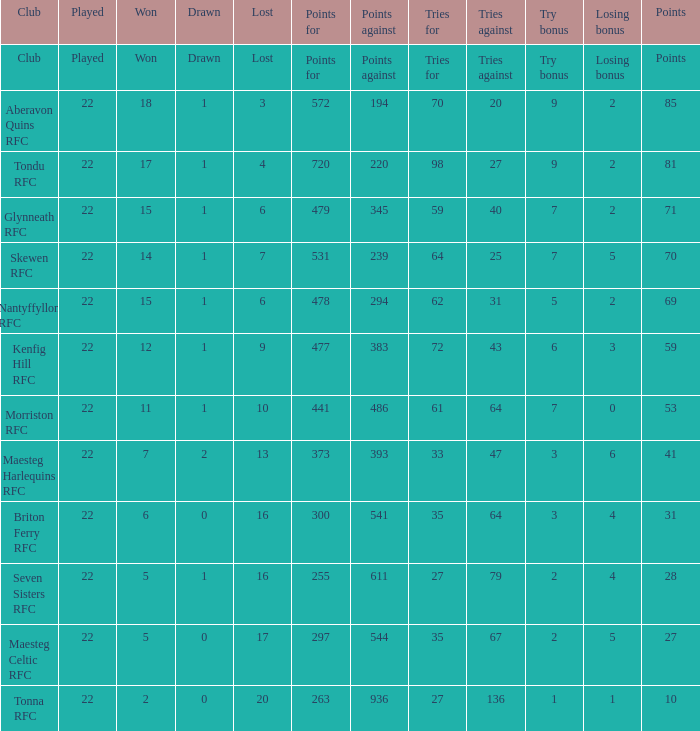Can you give me this table as a dict? {'header': ['Club', 'Played', 'Won', 'Drawn', 'Lost', 'Points for', 'Points against', 'Tries for', 'Tries against', 'Try bonus', 'Losing bonus', 'Points'], 'rows': [['Club', 'Played', 'Won', 'Drawn', 'Lost', 'Points for', 'Points against', 'Tries for', 'Tries against', 'Try bonus', 'Losing bonus', 'Points'], ['Aberavon Quins RFC', '22', '18', '1', '3', '572', '194', '70', '20', '9', '2', '85'], ['Tondu RFC', '22', '17', '1', '4', '720', '220', '98', '27', '9', '2', '81'], ['Glynneath RFC', '22', '15', '1', '6', '479', '345', '59', '40', '7', '2', '71'], ['Skewen RFC', '22', '14', '1', '7', '531', '239', '64', '25', '7', '5', '70'], ['Nantyffyllon RFC', '22', '15', '1', '6', '478', '294', '62', '31', '5', '2', '69'], ['Kenfig Hill RFC', '22', '12', '1', '9', '477', '383', '72', '43', '6', '3', '59'], ['Morriston RFC', '22', '11', '1', '10', '441', '486', '61', '64', '7', '0', '53'], ['Maesteg Harlequins RFC', '22', '7', '2', '13', '373', '393', '33', '47', '3', '6', '41'], ['Briton Ferry RFC', '22', '6', '0', '16', '300', '541', '35', '64', '3', '4', '31'], ['Seven Sisters RFC', '22', '5', '1', '16', '255', '611', '27', '79', '2', '4', '28'], ['Maesteg Celtic RFC', '22', '5', '0', '17', '297', '544', '35', '67', '2', '5', '27'], ['Tonna RFC', '22', '2', '0', '20', '263', '936', '27', '136', '1', '1', '10']]} How many attempts against has the club with 62 tries for secured? 31.0. 